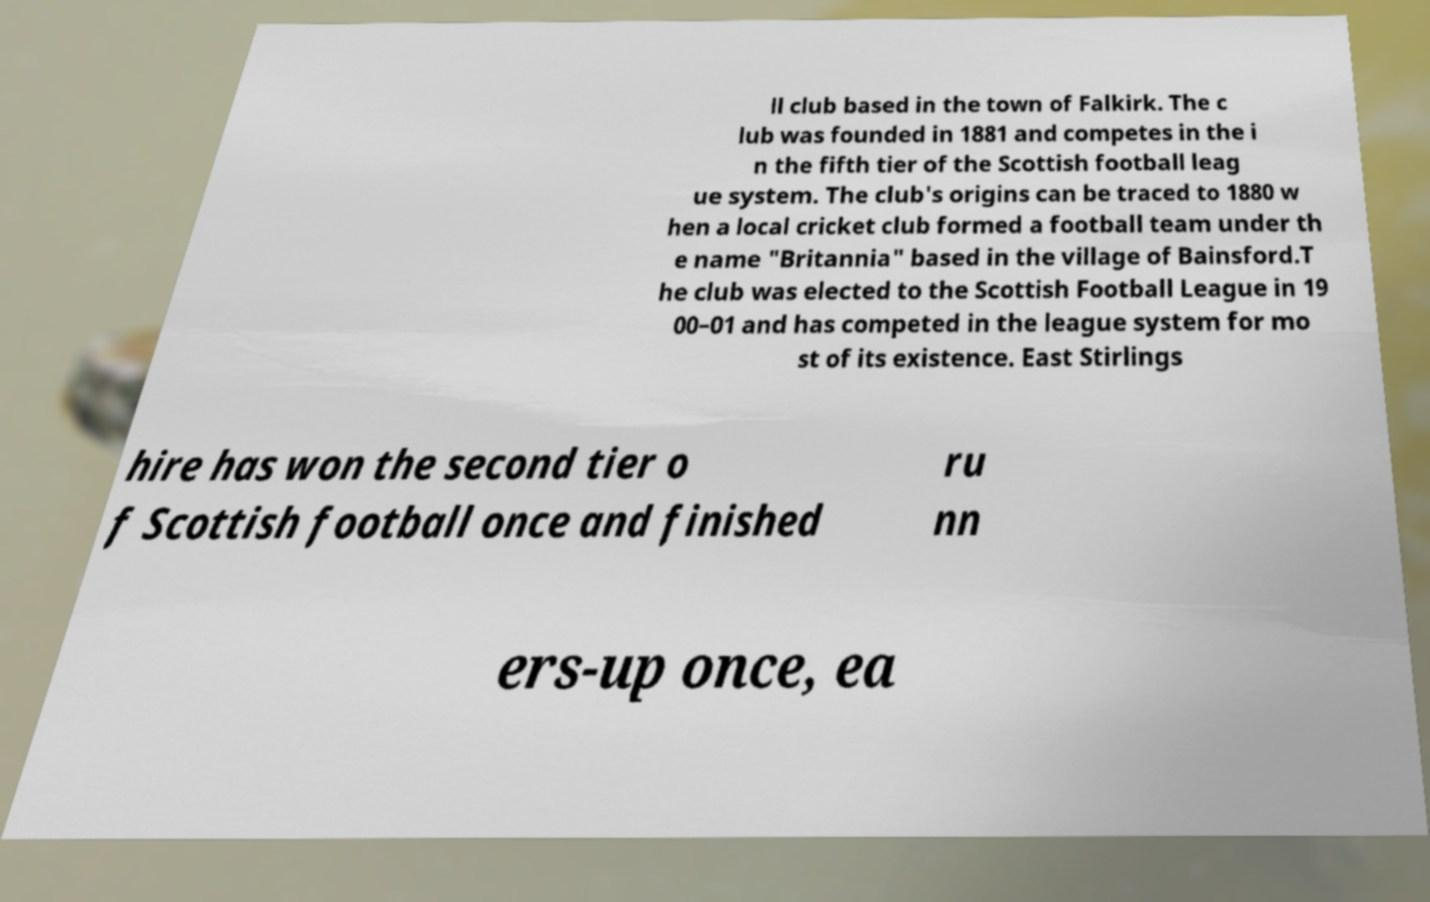For documentation purposes, I need the text within this image transcribed. Could you provide that? ll club based in the town of Falkirk. The c lub was founded in 1881 and competes in the i n the fifth tier of the Scottish football leag ue system. The club's origins can be traced to 1880 w hen a local cricket club formed a football team under th e name "Britannia" based in the village of Bainsford.T he club was elected to the Scottish Football League in 19 00–01 and has competed in the league system for mo st of its existence. East Stirlings hire has won the second tier o f Scottish football once and finished ru nn ers-up once, ea 